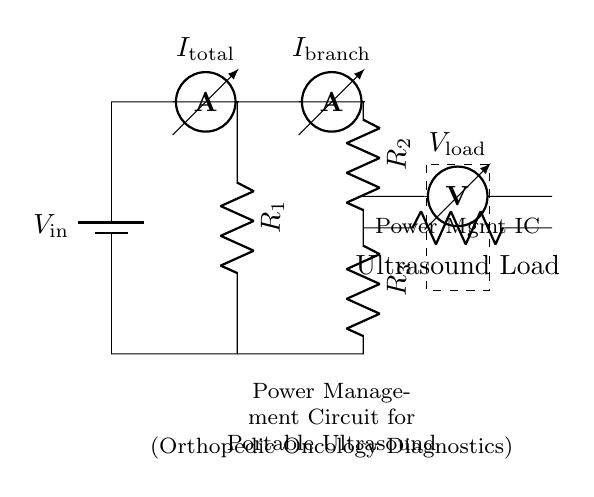What is the total current entering the circuit? The total current entering the circuit is indicated by the ammeter labeled with I_total, which measures the current flowing from the battery. To identify the value, one would typically measure this current in a practical scenario or calculate it based on the circuit parameters. Since this is a theoretical diagram, the specific value is not provided here.
Answer: I_total What components are in the current divider branch? The current divider branch consists of two resistors labeled R_2 and R_3. These elements are connected in series, which allows the total current to divide between them according to their resistance values.
Answer: R_2, R_3 What is the function of the Power Management IC? The Power Management IC regulates the supply and distribution of electrical power to the ultrasound load and other components in the circuit. It ensures efficient power usage and can manage different voltage levels required by various parts of the system.
Answer: Regulates power What is the voltage across the ultrasound load? The voltage across the ultrasound load is indicated by the voltmeter labeled V_load. It measures the potential difference across the load, which is crucial for determining how effectively the ultrasound device operates. The specific voltage value is not provided in the diagram, but it can be measured or calculated.
Answer: V_load How does current flow in the circuit? Current flows from the battery into the main path where it first encounters R_1. It then splits into two branches at the junction, flowing through R_2 and R_3. The respective resistances determine how much current goes through each branch before returning to the power source. An ammeter measures the total current and the branch current.
Answer: From battery to R_1, then divides through R_2 and R_3 What role does the ammeter play in this circuit? The ammeter is used to measure the current at two key points in the circuit: I_total measures the entire current coming from the battery, while I_branch measures the current specifically going through either R_2. This data can be critical for analyzing how the circuit distributes current among its components.
Answer: Measures current 